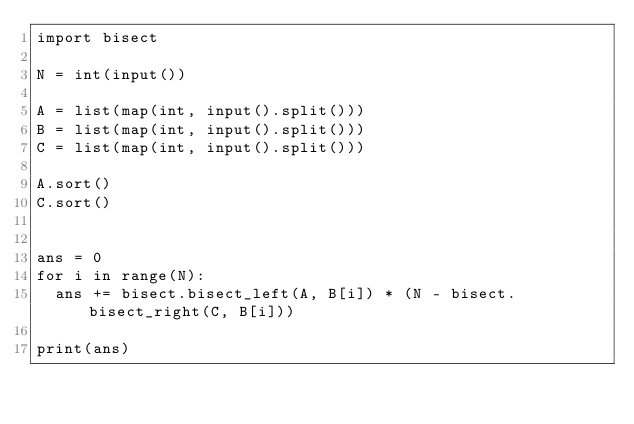Convert code to text. <code><loc_0><loc_0><loc_500><loc_500><_Python_>import bisect

N = int(input())

A = list(map(int, input().split()))
B = list(map(int, input().split()))
C = list(map(int, input().split()))

A.sort()
C.sort()


ans = 0
for i in range(N):
	ans += bisect.bisect_left(A, B[i]) * (N - bisect.bisect_right(C, B[i]))

print(ans)</code> 